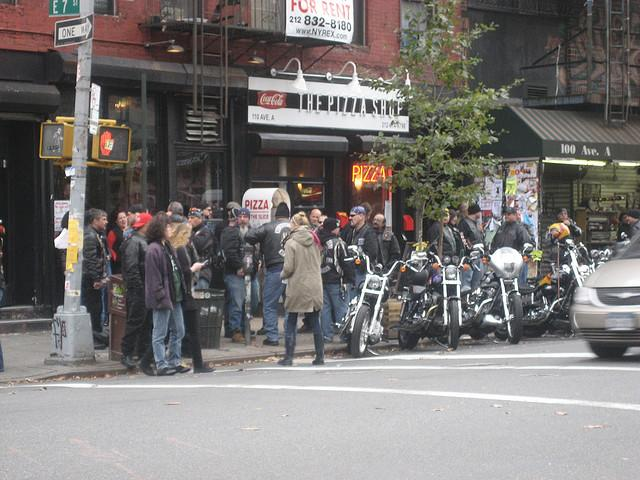What will the bikers shown here have for lunch today? pizza 